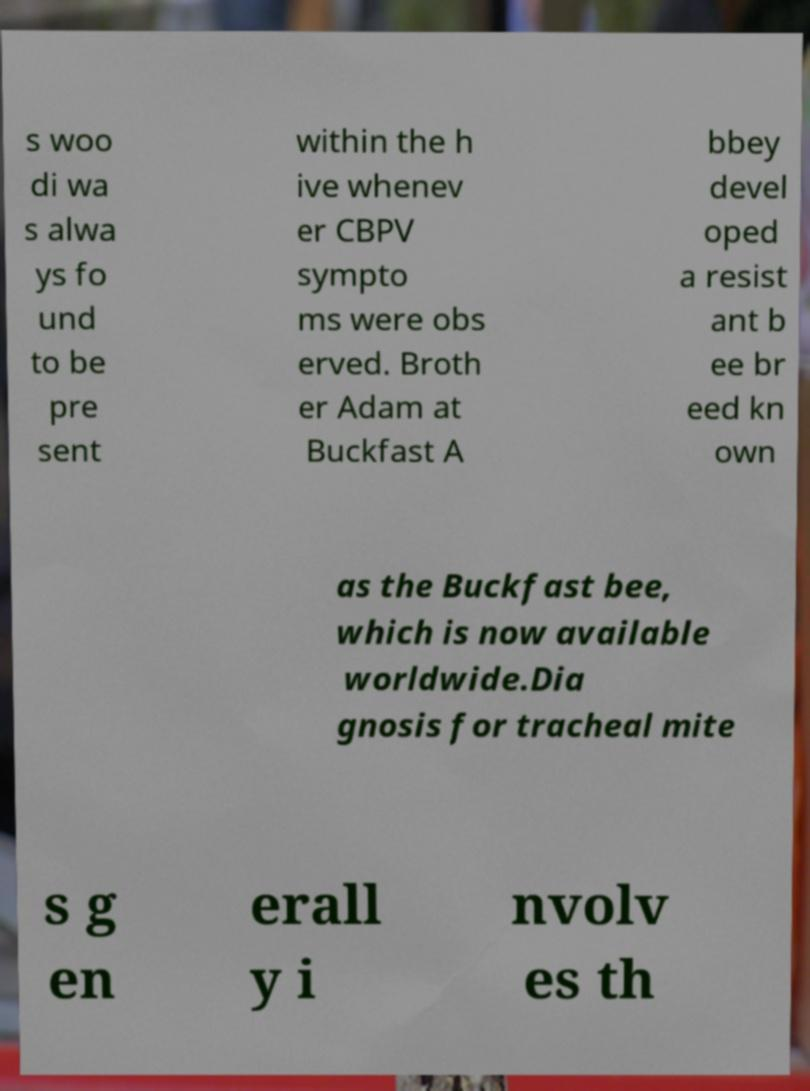Could you extract and type out the text from this image? s woo di wa s alwa ys fo und to be pre sent within the h ive whenev er CBPV sympto ms were obs erved. Broth er Adam at Buckfast A bbey devel oped a resist ant b ee br eed kn own as the Buckfast bee, which is now available worldwide.Dia gnosis for tracheal mite s g en erall y i nvolv es th 